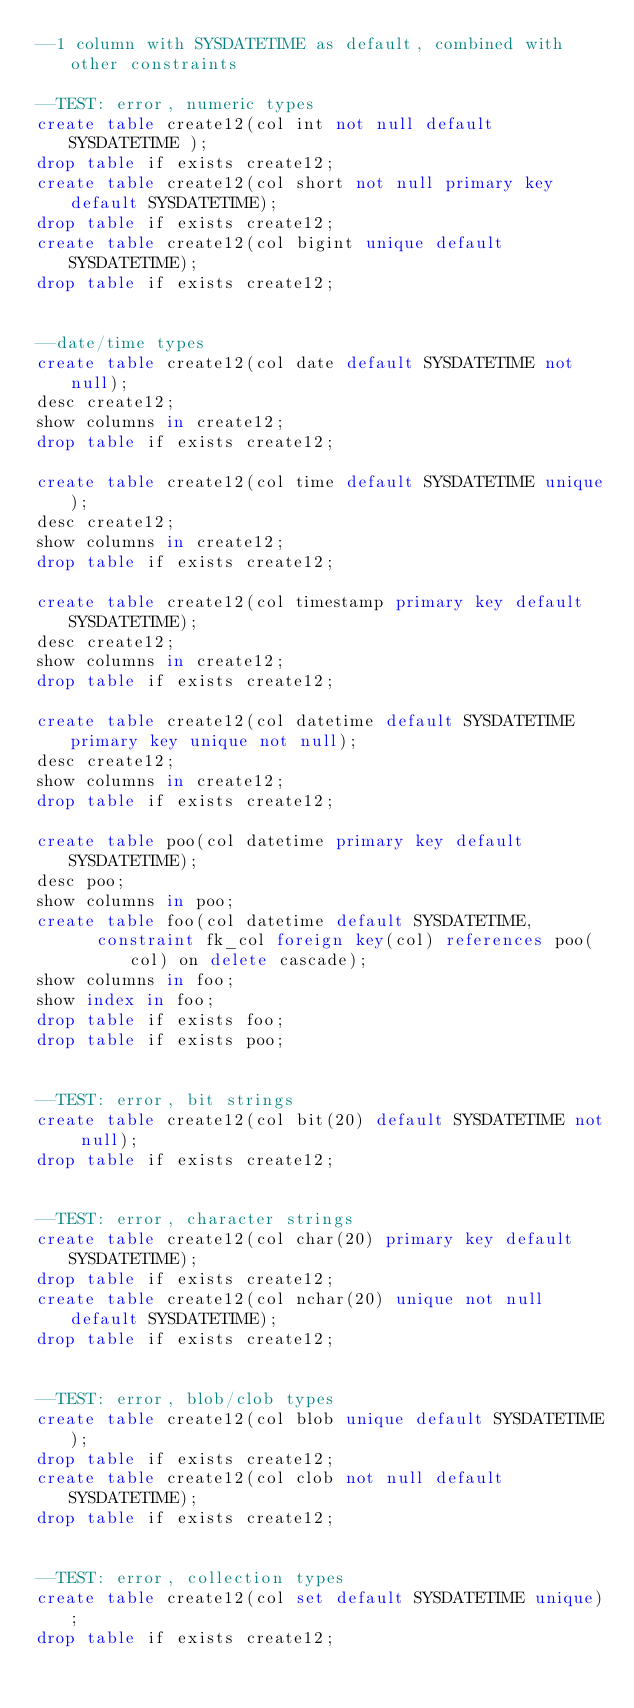<code> <loc_0><loc_0><loc_500><loc_500><_SQL_>--1 column with SYSDATETIME as default, combined with other constraints

--TEST: error, numeric types
create table create12(col int not null default SYSDATETIME );
drop table if exists create12;
create table create12(col short not null primary key default SYSDATETIME);
drop table if exists create12;
create table create12(col bigint unique default SYSDATETIME);
drop table if exists create12;


--date/time types
create table create12(col date default SYSDATETIME not null);
desc create12;
show columns in create12;
drop table if exists create12;

create table create12(col time default SYSDATETIME unique);
desc create12;
show columns in create12;
drop table if exists create12;

create table create12(col timestamp primary key default SYSDATETIME);
desc create12;
show columns in create12;
drop table if exists create12;

create table create12(col datetime default SYSDATETIME primary key unique not null);
desc create12;
show columns in create12;
drop table if exists create12;

create table poo(col datetime primary key default SYSDATETIME);
desc poo;
show columns in poo;
create table foo(col datetime default SYSDATETIME, 
			constraint fk_col foreign key(col) references poo(col) on delete cascade);
show columns in foo;
show index in foo;
drop table if exists foo;
drop table if exists poo;


--TEST: error, bit strings
create table create12(col bit(20) default SYSDATETIME not null);
drop table if exists create12;


--TEST: error, character strings
create table create12(col char(20) primary key default SYSDATETIME);
drop table if exists create12;
create table create12(col nchar(20) unique not null default SYSDATETIME);
drop table if exists create12;


--TEST: error, blob/clob types
create table create12(col blob unique default SYSDATETIME);
drop table if exists create12;
create table create12(col clob not null default SYSDATETIME);
drop table if exists create12;


--TEST: error, collection types
create table create12(col set default SYSDATETIME unique);
drop table if exists create12;








</code> 